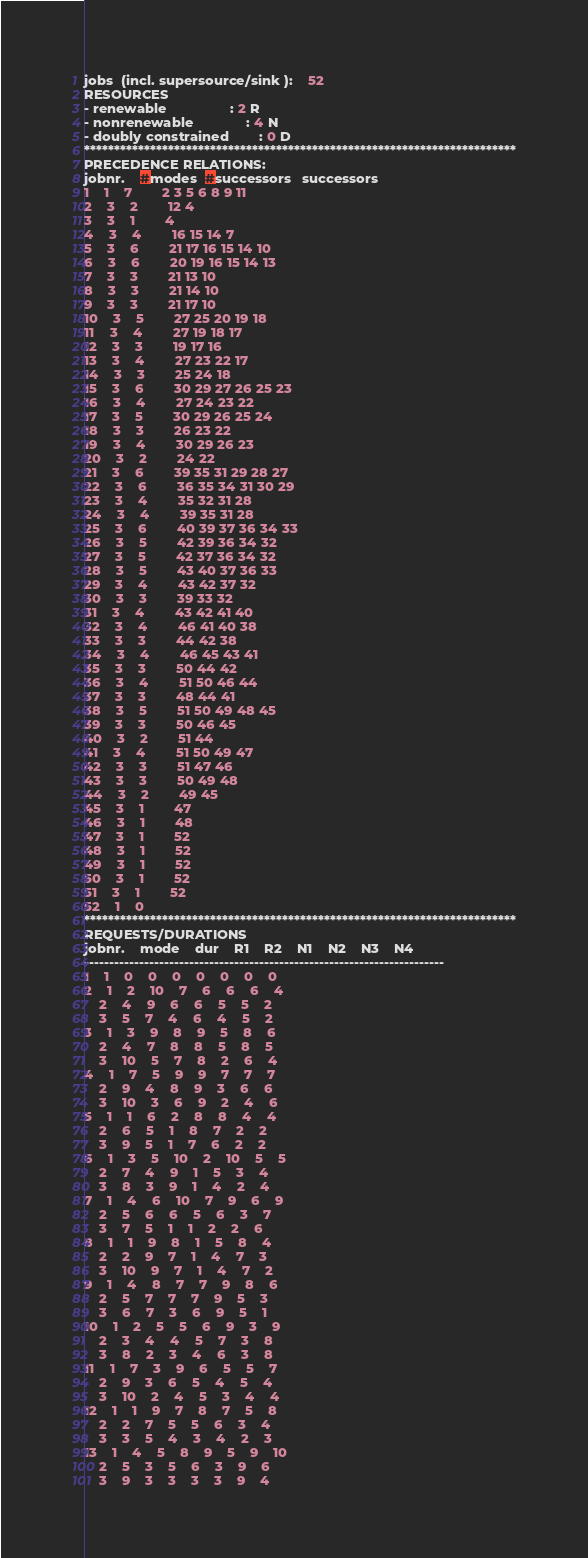<code> <loc_0><loc_0><loc_500><loc_500><_ObjectiveC_>jobs  (incl. supersource/sink ):	52
RESOURCES
- renewable                 : 2 R
- nonrenewable              : 4 N
- doubly constrained        : 0 D
************************************************************************
PRECEDENCE RELATIONS:
jobnr.    #modes  #successors   successors
1	1	7		2 3 5 6 8 9 11 
2	3	2		12 4 
3	3	1		4 
4	3	4		16 15 14 7 
5	3	6		21 17 16 15 14 10 
6	3	6		20 19 16 15 14 13 
7	3	3		21 13 10 
8	3	3		21 14 10 
9	3	3		21 17 10 
10	3	5		27 25 20 19 18 
11	3	4		27 19 18 17 
12	3	3		19 17 16 
13	3	4		27 23 22 17 
14	3	3		25 24 18 
15	3	6		30 29 27 26 25 23 
16	3	4		27 24 23 22 
17	3	5		30 29 26 25 24 
18	3	3		26 23 22 
19	3	4		30 29 26 23 
20	3	2		24 22 
21	3	6		39 35 31 29 28 27 
22	3	6		36 35 34 31 30 29 
23	3	4		35 32 31 28 
24	3	4		39 35 31 28 
25	3	6		40 39 37 36 34 33 
26	3	5		42 39 36 34 32 
27	3	5		42 37 36 34 32 
28	3	5		43 40 37 36 33 
29	3	4		43 42 37 32 
30	3	3		39 33 32 
31	3	4		43 42 41 40 
32	3	4		46 41 40 38 
33	3	3		44 42 38 
34	3	4		46 45 43 41 
35	3	3		50 44 42 
36	3	4		51 50 46 44 
37	3	3		48 44 41 
38	3	5		51 50 49 48 45 
39	3	3		50 46 45 
40	3	2		51 44 
41	3	4		51 50 49 47 
42	3	3		51 47 46 
43	3	3		50 49 48 
44	3	2		49 45 
45	3	1		47 
46	3	1		48 
47	3	1		52 
48	3	1		52 
49	3	1		52 
50	3	1		52 
51	3	1		52 
52	1	0		
************************************************************************
REQUESTS/DURATIONS
jobnr.	mode	dur	R1	R2	N1	N2	N3	N4	
------------------------------------------------------------------------
1	1	0	0	0	0	0	0	0	
2	1	2	10	7	6	6	6	4	
	2	4	9	6	6	5	5	2	
	3	5	7	4	6	4	5	2	
3	1	3	9	8	9	5	8	6	
	2	4	7	8	8	5	8	5	
	3	10	5	7	8	2	6	4	
4	1	7	5	9	9	7	7	7	
	2	9	4	8	9	3	6	6	
	3	10	3	6	9	2	4	6	
5	1	1	6	2	8	8	4	4	
	2	6	5	1	8	7	2	2	
	3	9	5	1	7	6	2	2	
6	1	3	5	10	2	10	5	5	
	2	7	4	9	1	5	3	4	
	3	8	3	9	1	4	2	4	
7	1	4	6	10	7	9	6	9	
	2	5	6	6	5	6	3	7	
	3	7	5	1	1	2	2	6	
8	1	1	9	8	1	5	8	4	
	2	2	9	7	1	4	7	3	
	3	10	9	7	1	4	7	2	
9	1	4	8	7	7	9	8	6	
	2	5	7	7	7	9	5	3	
	3	6	7	3	6	9	5	1	
10	1	2	5	5	6	9	3	9	
	2	3	4	4	5	7	3	8	
	3	8	2	3	4	6	3	8	
11	1	7	3	9	6	5	5	7	
	2	9	3	6	5	4	5	4	
	3	10	2	4	5	3	4	4	
12	1	1	9	7	8	7	5	8	
	2	2	7	5	5	6	3	4	
	3	3	5	4	3	4	2	3	
13	1	4	5	8	9	5	9	10	
	2	5	3	5	6	3	9	6	
	3	9	3	3	3	3	9	4	</code> 